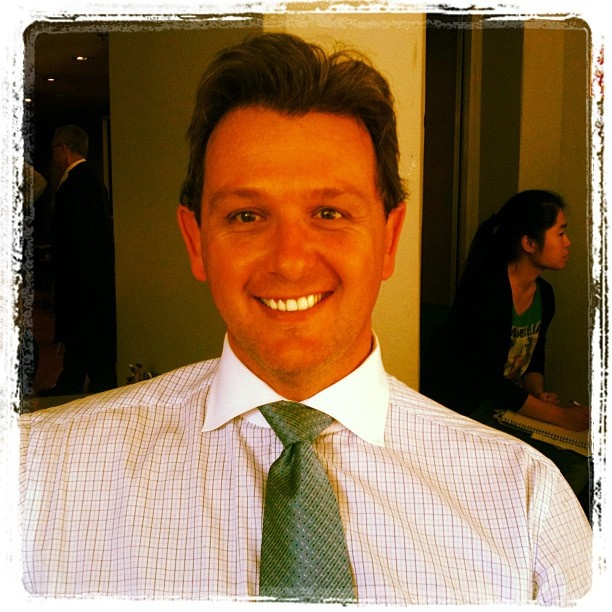Describe the objects in this image and their specific colors. I can see people in white, lightgray, red, black, and tan tones, people in white, black, maroon, and olive tones, people in white, black, maroon, and olive tones, and tie in white, darkgreen, gray, and olive tones in this image. 